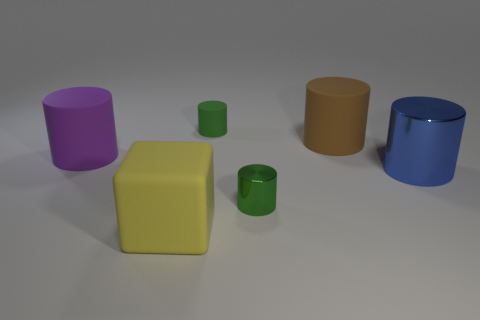Subtract all small green metallic cylinders. How many cylinders are left? 4 Subtract all green cubes. How many green cylinders are left? 2 Subtract all blue cylinders. How many cylinders are left? 4 Add 1 cylinders. How many objects exist? 7 Subtract all blocks. How many objects are left? 5 Subtract all yellow cylinders. Subtract all purple blocks. How many cylinders are left? 5 Subtract 0 red blocks. How many objects are left? 6 Subtract all large cubes. Subtract all rubber objects. How many objects are left? 1 Add 3 purple matte objects. How many purple matte objects are left? 4 Add 5 blue objects. How many blue objects exist? 6 